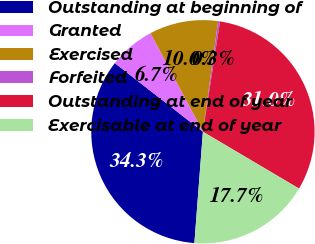Convert chart to OTSL. <chart><loc_0><loc_0><loc_500><loc_500><pie_chart><fcel>Outstanding at beginning of<fcel>Granted<fcel>Exercised<fcel>Forfeited<fcel>Outstanding at end of year<fcel>Exercisable at end of year<nl><fcel>34.32%<fcel>6.69%<fcel>9.96%<fcel>0.27%<fcel>31.05%<fcel>17.72%<nl></chart> 